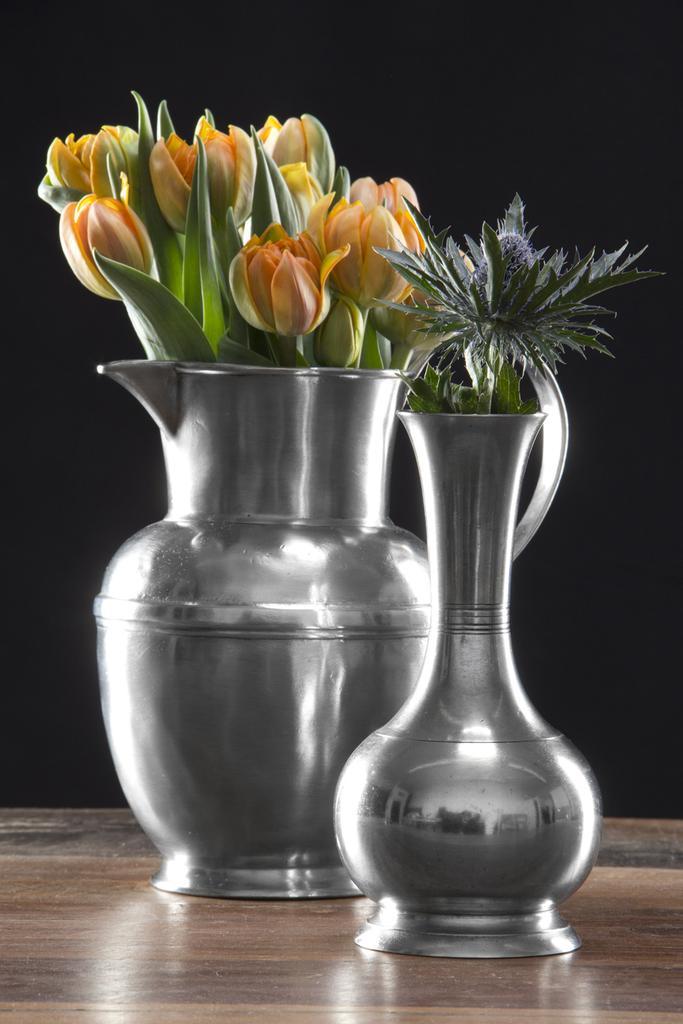Describe this image in one or two sentences. Here in this picture we can see flower plants present in metal vases, which are present on the table over there. 